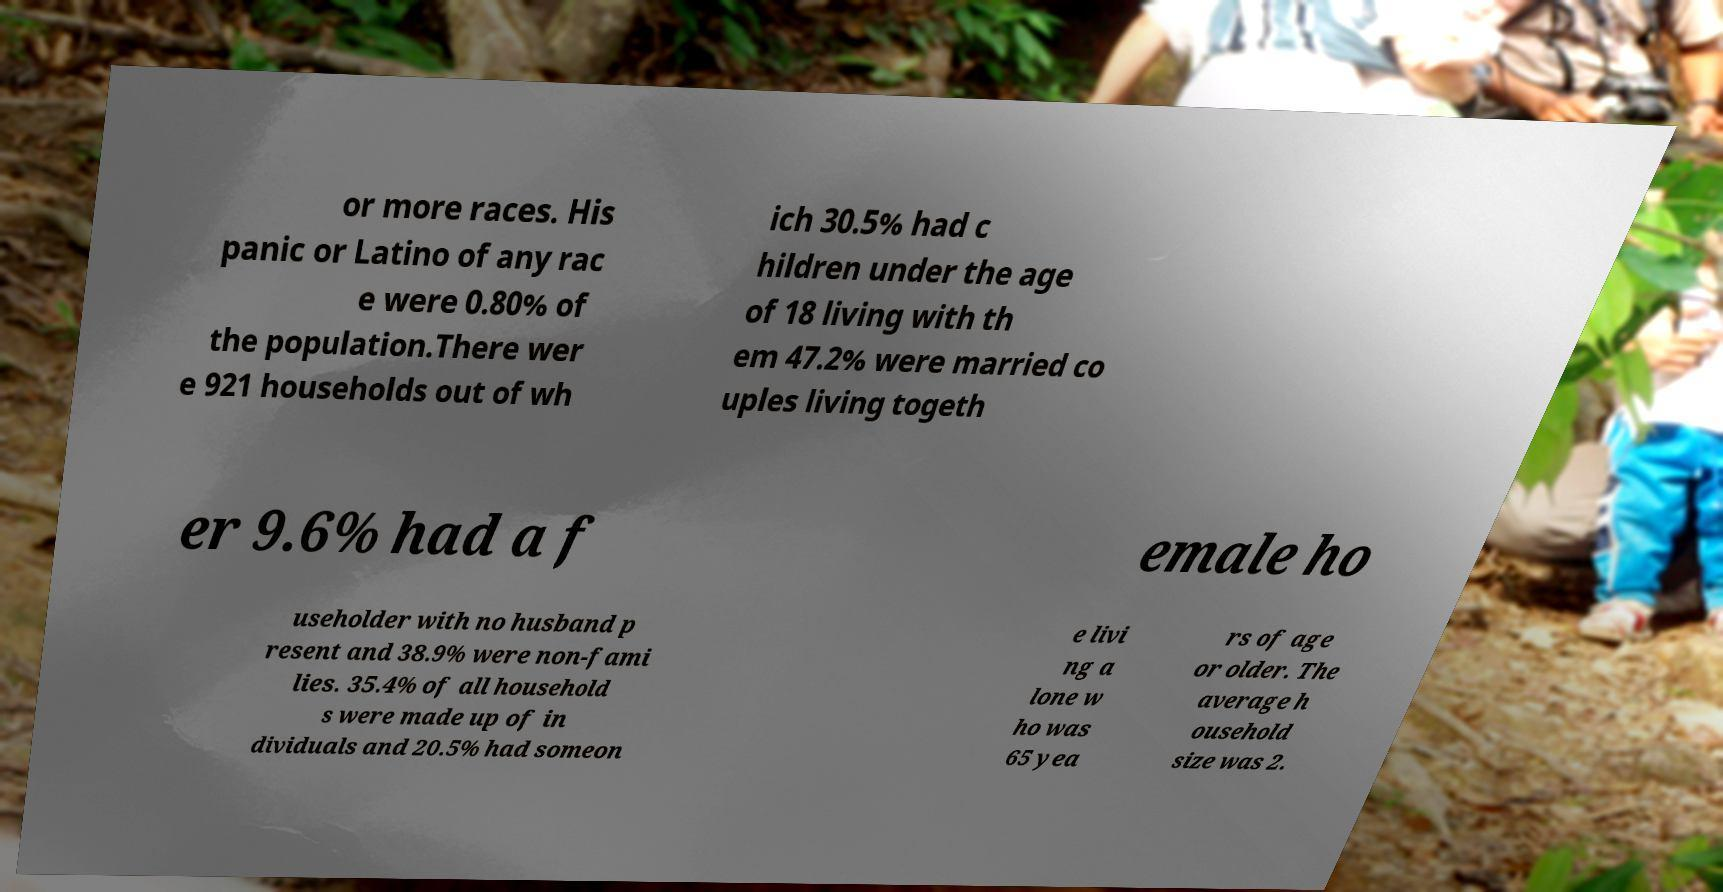Please identify and transcribe the text found in this image. or more races. His panic or Latino of any rac e were 0.80% of the population.There wer e 921 households out of wh ich 30.5% had c hildren under the age of 18 living with th em 47.2% were married co uples living togeth er 9.6% had a f emale ho useholder with no husband p resent and 38.9% were non-fami lies. 35.4% of all household s were made up of in dividuals and 20.5% had someon e livi ng a lone w ho was 65 yea rs of age or older. The average h ousehold size was 2. 